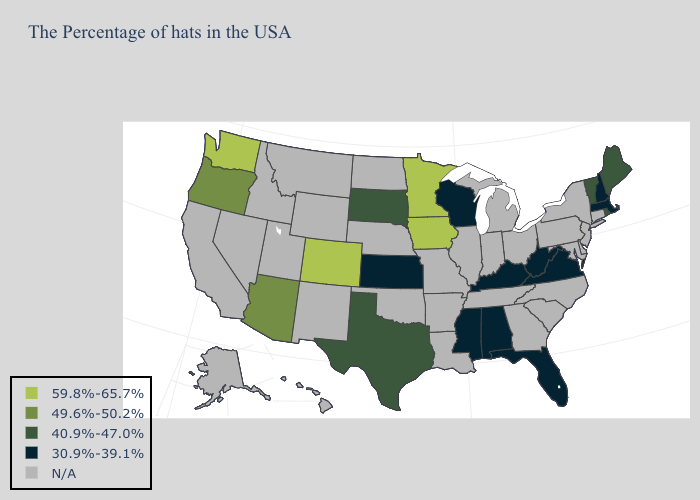What is the value of Rhode Island?
Keep it brief. 40.9%-47.0%. Which states have the lowest value in the Northeast?
Quick response, please. Massachusetts, New Hampshire. Does the first symbol in the legend represent the smallest category?
Answer briefly. No. What is the lowest value in states that border Colorado?
Quick response, please. 30.9%-39.1%. What is the value of Illinois?
Keep it brief. N/A. What is the highest value in states that border Iowa?
Keep it brief. 59.8%-65.7%. What is the value of Indiana?
Short answer required. N/A. What is the value of Indiana?
Be succinct. N/A. What is the highest value in the USA?
Keep it brief. 59.8%-65.7%. Among the states that border Wisconsin , which have the lowest value?
Keep it brief. Minnesota, Iowa. What is the value of Pennsylvania?
Write a very short answer. N/A. What is the highest value in the USA?
Answer briefly. 59.8%-65.7%. 